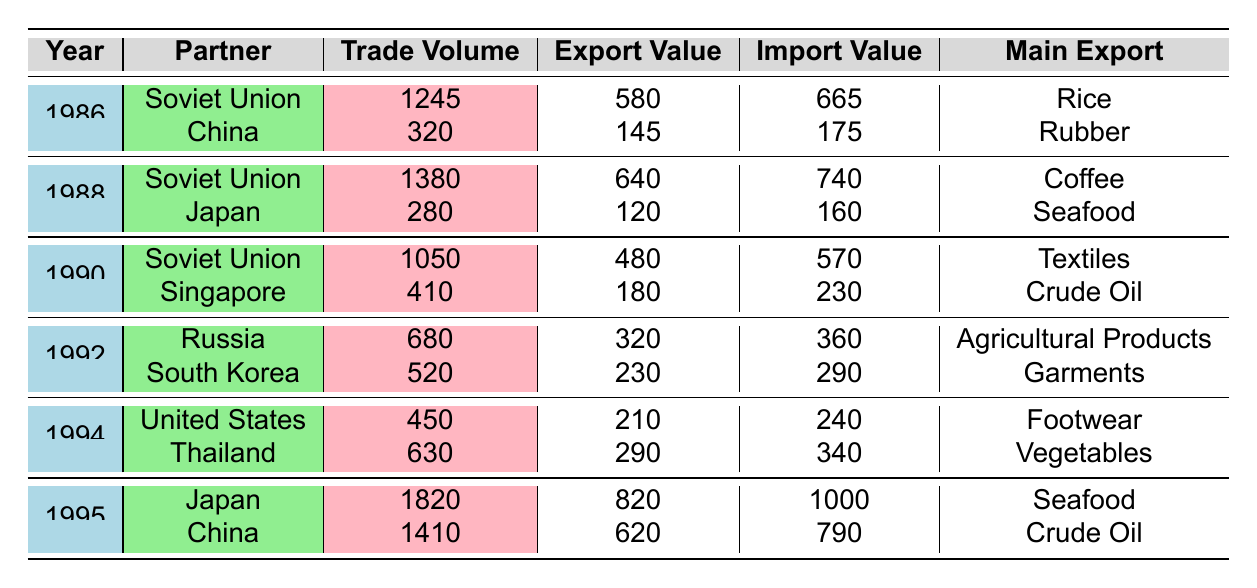What was the trade volume between Vietnam and China in 1995? Referring to the table, in 1995, under the China row, the trade volume is listed as 1410 million USD.
Answer: 1410 million USD Which partner had the highest trade volume in 1995? Looking at the year 1995, the Japan row shows a trade volume of 1820 million USD, which is higher than the trade volume with China (1410 million USD).
Answer: Japan What is the trade balance with the Soviet Union in 1988? From the table, in 1988, the trade balance for the Soviet Union is listed as -100 million USD, indicating more imports than exports.
Answer: -100 million USD What was the average export value for Vietnam's trade partners in 1990? For 1990, the export values are 480 million USD (Soviet Union) and 180 million USD (Singapore). Adding these gives 660 million USD. Dividing by 2 (the number of partners) gives an average of 330 million USD.
Answer: 330 million USD Did Vietnam have a positive trade balance with any partner in 1986? The trade balances for both partners in 1986 (Soviet Union: -85 million USD, China: -30 million USD) are negative, indicating a deficit in both cases.
Answer: No Which partner had the main export value of seafood in 1995, and what was the import value? In 1995, Japan is listed as the partner with seafood as the main export, with an import value of 1000 million USD.
Answer: Japan, 1000 million USD Calculate the total trade volume with the Soviet Union from 1986 to 1990. The trade volumes with the Soviet Union across the years 1986 (1245 million USD), 1988 (1380 million USD), and 1990 (1050 million USD) sum as follows: 1245 + 1380 + 1050 = 3675 million USD.
Answer: 3675 million USD In which year did Vietnam trade with South Korea, and what was the import value? Referring to the table, Vietnam traded with South Korea in 1992, with an import value of 290 million USD.
Answer: 1992, 290 million USD What was the main import product from Thailand in 1994? The table shows that in 1994, the main import from Thailand was plastics, as listed under that row.
Answer: Plastics 